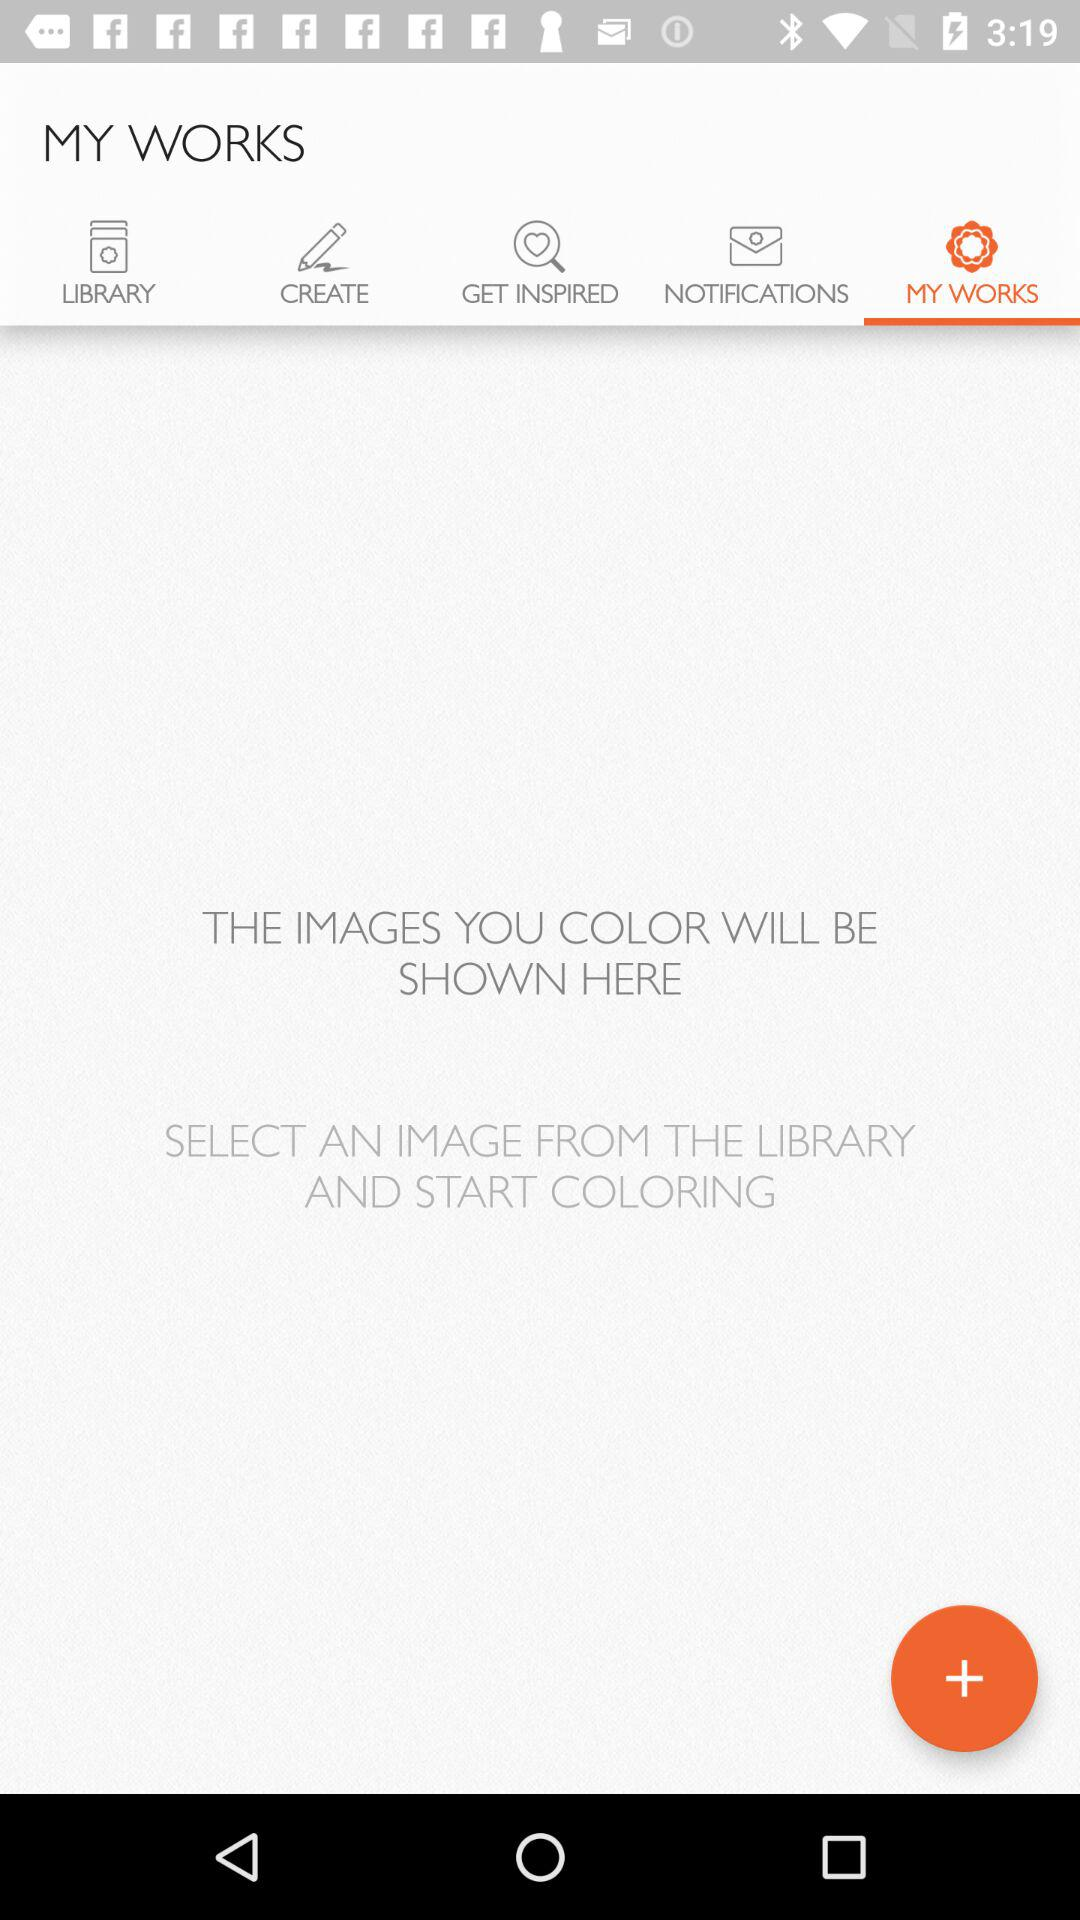Which tab is selected? The selected tab is "MY WORKS". 